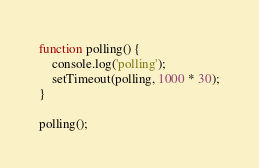Convert code to text. <code><loc_0><loc_0><loc_500><loc_500><_TypeScript_>
function polling() {
    console.log('polling');
    setTimeout(polling, 1000 * 30);
}

polling();

</code> 